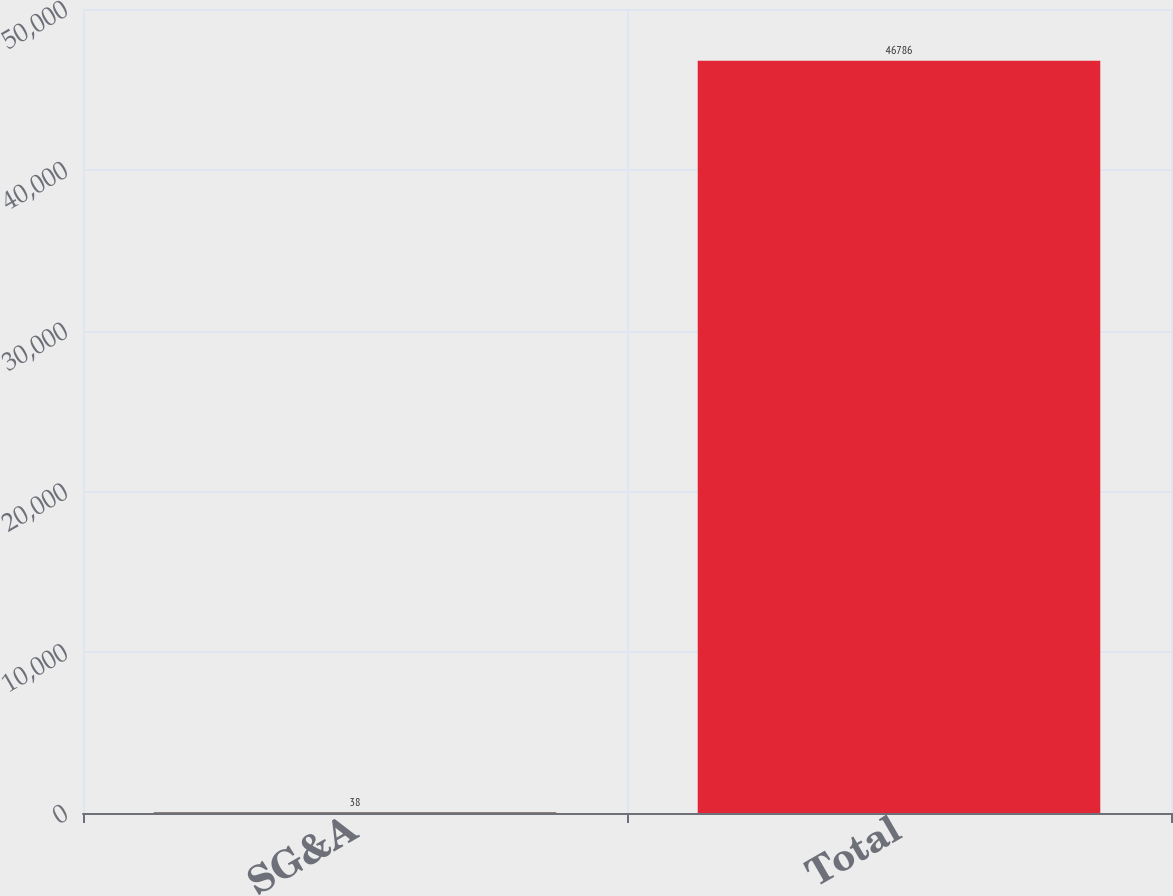<chart> <loc_0><loc_0><loc_500><loc_500><bar_chart><fcel>SG&A<fcel>Total<nl><fcel>38<fcel>46786<nl></chart> 